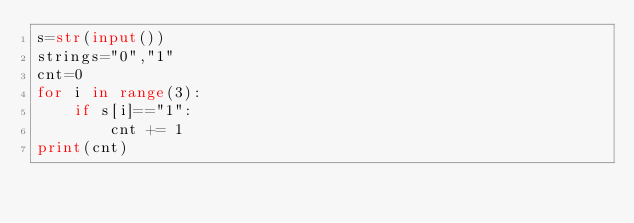<code> <loc_0><loc_0><loc_500><loc_500><_Python_>s=str(input())
strings="0","1"
cnt=0
for i in range(3):
    if s[i]=="1":
        cnt += 1
print(cnt)</code> 